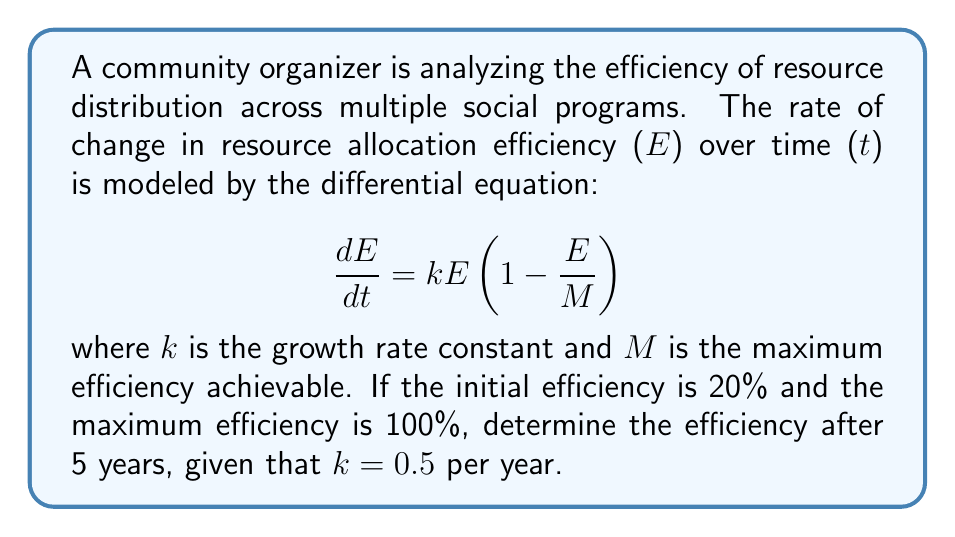Give your solution to this math problem. To solve this problem, we need to follow these steps:

1) Recognize that this is a logistic growth differential equation.

2) The general solution for the logistic growth equation is:

   $$E(t) = \frac{M}{1 + (\frac{M}{E_0} - 1)e^{-kt}}$$

   where $E_0$ is the initial efficiency.

3) We're given:
   - $E_0 = 20\% = 0.2$
   - $M = 100\% = 1$
   - $k = 0.5$ per year
   - $t = 5$ years

4) Substitute these values into the equation:

   $$E(5) = \frac{1}{1 + (\frac{1}{0.2} - 1)e^{-0.5(5)}}$$

5) Simplify:
   $$E(5) = \frac{1}{1 + 4e^{-2.5}}$$

6) Calculate $e^{-2.5} \approx 0.0821$

7) Substitute and calculate:

   $$E(5) = \frac{1}{1 + 4(0.0821)} \approx 0.7523$$

8) Convert to percentage: 0.7523 * 100% ≈ 75.23%

Therefore, after 5 years, the efficiency of resource distribution will be approximately 75.23%.
Answer: The efficiency of resource distribution across the social programs after 5 years will be approximately 75.23%. 